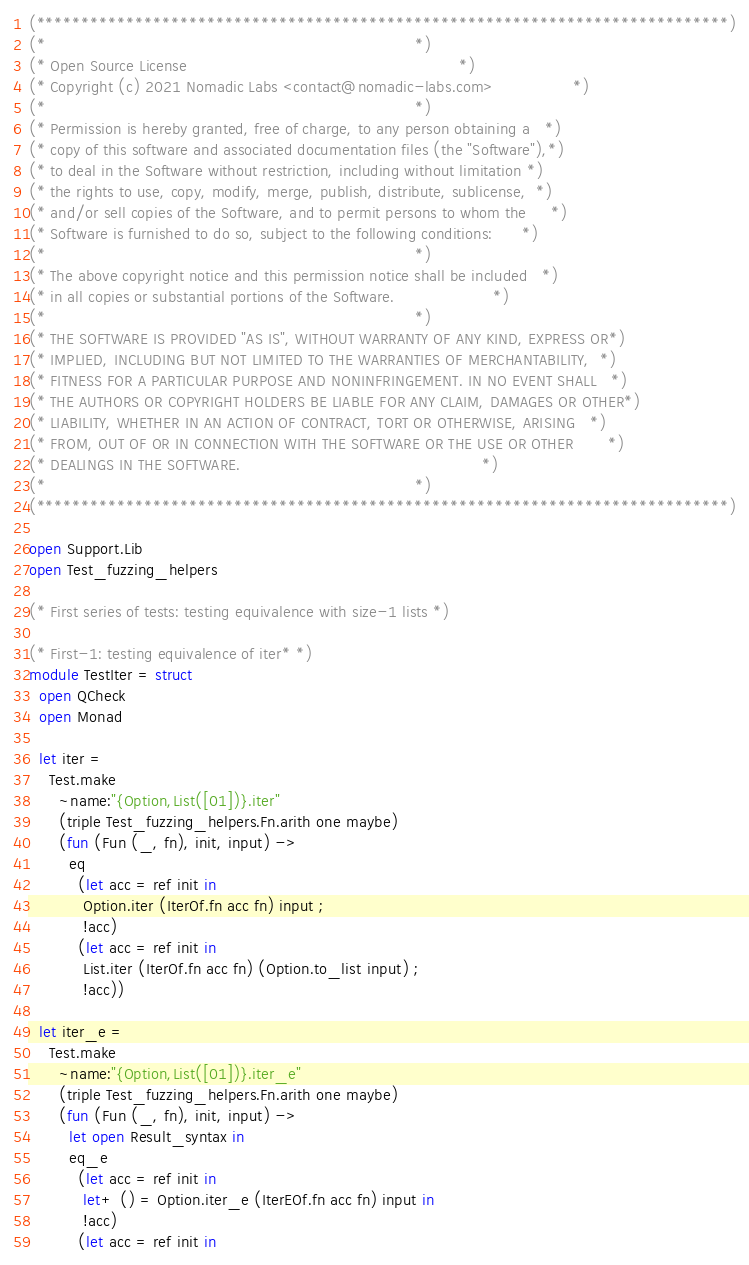<code> <loc_0><loc_0><loc_500><loc_500><_OCaml_>(*****************************************************************************)
(*                                                                           *)
(* Open Source License                                                       *)
(* Copyright (c) 2021 Nomadic Labs <contact@nomadic-labs.com>                *)
(*                                                                           *)
(* Permission is hereby granted, free of charge, to any person obtaining a   *)
(* copy of this software and associated documentation files (the "Software"),*)
(* to deal in the Software without restriction, including without limitation *)
(* the rights to use, copy, modify, merge, publish, distribute, sublicense,  *)
(* and/or sell copies of the Software, and to permit persons to whom the     *)
(* Software is furnished to do so, subject to the following conditions:      *)
(*                                                                           *)
(* The above copyright notice and this permission notice shall be included   *)
(* in all copies or substantial portions of the Software.                    *)
(*                                                                           *)
(* THE SOFTWARE IS PROVIDED "AS IS", WITHOUT WARRANTY OF ANY KIND, EXPRESS OR*)
(* IMPLIED, INCLUDING BUT NOT LIMITED TO THE WARRANTIES OF MERCHANTABILITY,  *)
(* FITNESS FOR A PARTICULAR PURPOSE AND NONINFRINGEMENT. IN NO EVENT SHALL   *)
(* THE AUTHORS OR COPYRIGHT HOLDERS BE LIABLE FOR ANY CLAIM, DAMAGES OR OTHER*)
(* LIABILITY, WHETHER IN AN ACTION OF CONTRACT, TORT OR OTHERWISE, ARISING   *)
(* FROM, OUT OF OR IN CONNECTION WITH THE SOFTWARE OR THE USE OR OTHER       *)
(* DEALINGS IN THE SOFTWARE.                                                 *)
(*                                                                           *)
(*****************************************************************************)

open Support.Lib
open Test_fuzzing_helpers

(* First series of tests: testing equivalence with size-1 lists *)

(* First-1: testing equivalence of iter* *)
module TestIter = struct
  open QCheck
  open Monad

  let iter =
    Test.make
      ~name:"{Option,List([01])}.iter"
      (triple Test_fuzzing_helpers.Fn.arith one maybe)
      (fun (Fun (_, fn), init, input) ->
        eq
          (let acc = ref init in
           Option.iter (IterOf.fn acc fn) input ;
           !acc)
          (let acc = ref init in
           List.iter (IterOf.fn acc fn) (Option.to_list input) ;
           !acc))

  let iter_e =
    Test.make
      ~name:"{Option,List([01])}.iter_e"
      (triple Test_fuzzing_helpers.Fn.arith one maybe)
      (fun (Fun (_, fn), init, input) ->
        let open Result_syntax in
        eq_e
          (let acc = ref init in
           let+ () = Option.iter_e (IterEOf.fn acc fn) input in
           !acc)
          (let acc = ref init in</code> 